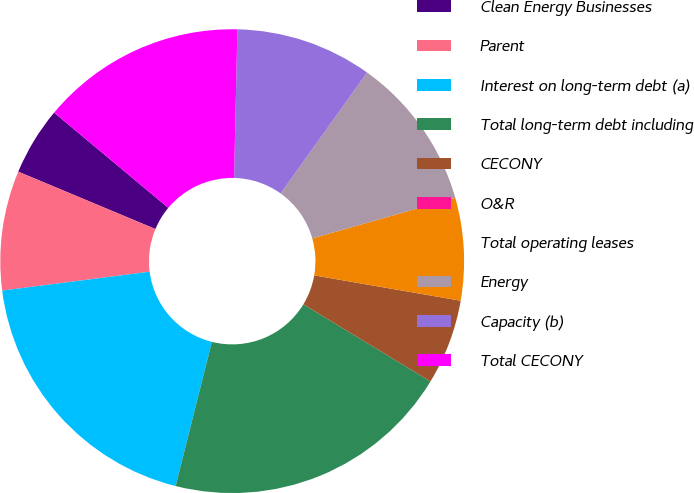<chart> <loc_0><loc_0><loc_500><loc_500><pie_chart><fcel>Clean Energy Businesses<fcel>Parent<fcel>Interest on long-term debt (a)<fcel>Total long-term debt including<fcel>CECONY<fcel>O&R<fcel>Total operating leases<fcel>Energy<fcel>Capacity (b)<fcel>Total CECONY<nl><fcel>4.76%<fcel>8.33%<fcel>19.05%<fcel>20.24%<fcel>5.95%<fcel>0.0%<fcel>7.14%<fcel>10.71%<fcel>9.52%<fcel>14.29%<nl></chart> 